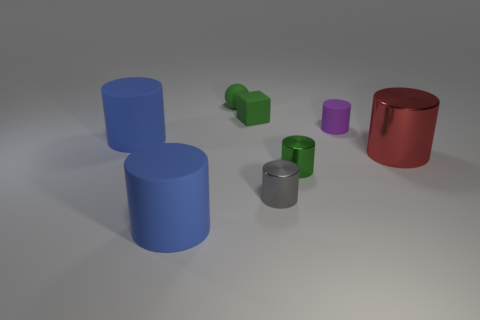Is there a tiny green block that has the same material as the gray thing?
Ensure brevity in your answer.  No. Is the material of the green cylinder the same as the purple cylinder?
Make the answer very short. No. What is the color of the block that is the same size as the green ball?
Ensure brevity in your answer.  Green. What number of other objects are the same shape as the red metallic thing?
Offer a very short reply. 5. There is a green matte block; is its size the same as the matte cylinder that is right of the small green matte sphere?
Your answer should be very brief. Yes. What number of things are either blue rubber objects or tiny gray metallic cylinders?
Provide a short and direct response. 3. What number of other things are the same size as the purple cylinder?
Offer a terse response. 4. There is a tiny rubber block; does it have the same color as the metallic cylinder that is right of the purple matte thing?
Your answer should be very brief. No. How many cylinders are either tiny purple rubber things or big metal things?
Keep it short and to the point. 2. Is there any other thing that is the same color as the rubber sphere?
Make the answer very short. Yes. 